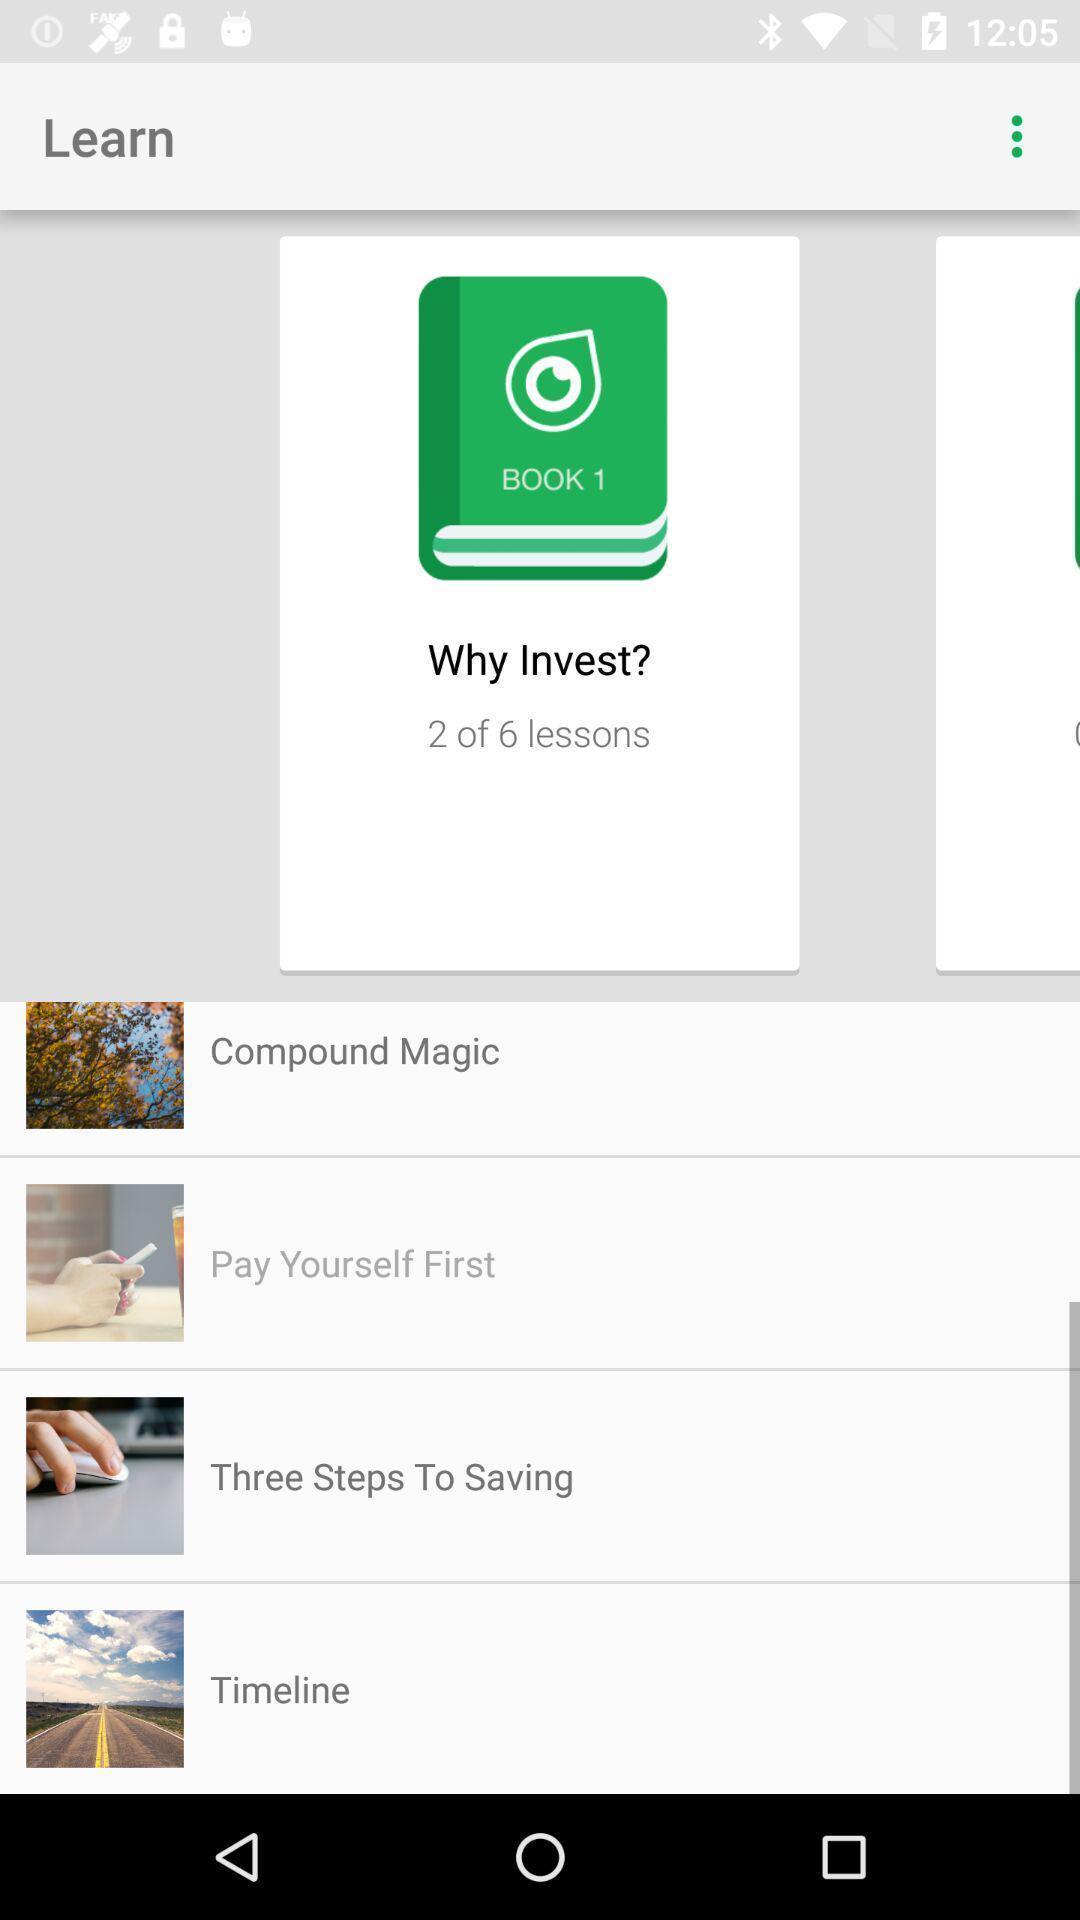Explain the elements present in this screenshot. Screen shows book 1 details in a learning app. 